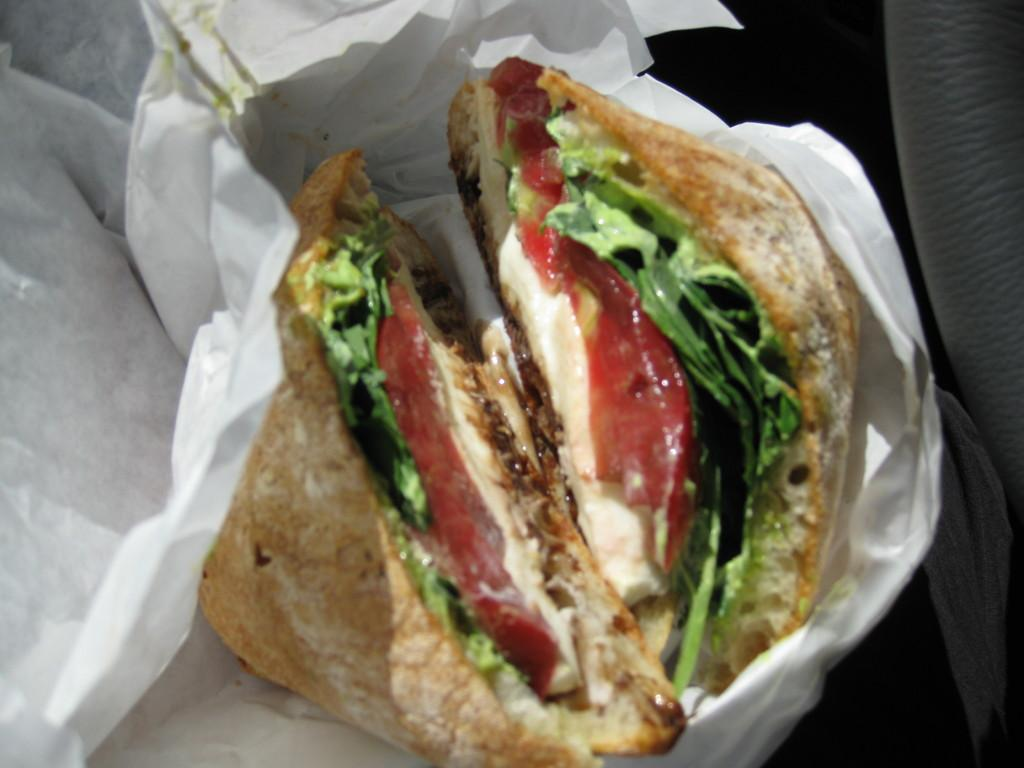What is the main subject of the picture? The main subject of the picture is a food item. Can you describe the food item in more detail? The food item appears to be a burger. How is the burger packaged or presented? The burger is wrapped in paper. What other objects can be seen in the image? There are other objects visible in the image. How many chickens are visible in the image? There are no chickens visible in the image. What is the rate at which the bread is being consumed in the image? There is no bread being consumed in the image, and therefore no rate can be determined. 